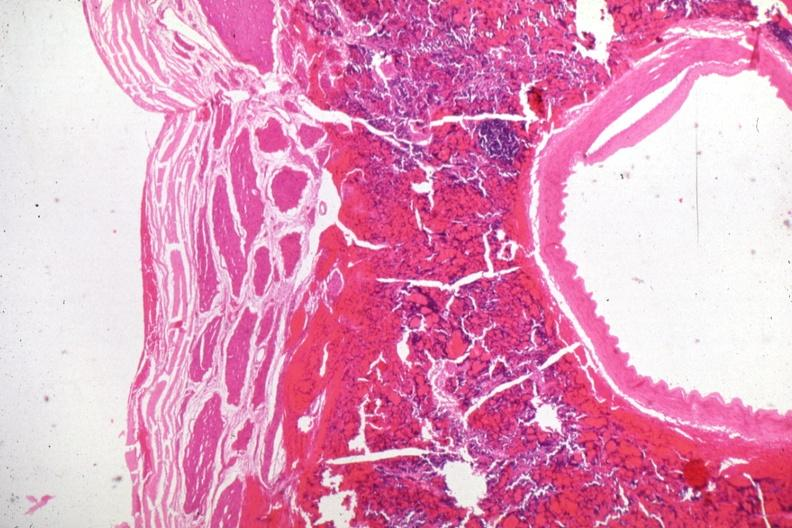does this image show carotid artery in region of pituitary with tumor cells in soft tissue?
Answer the question using a single word or phrase. Yes 